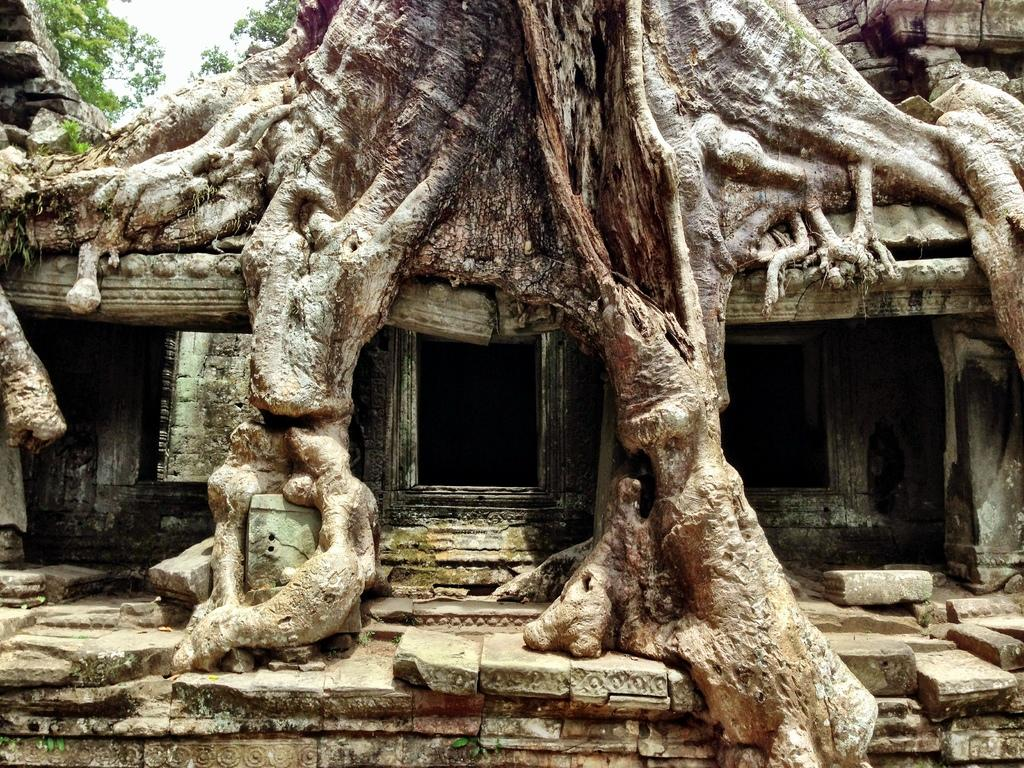What type of natural elements can be seen in the image? There are trees in the image. What architectural features are present in the image? There are windows in the image. What type of material is visible in the image? There is stone in the image. What is the color of the sky in the image? The sky is white in color. What type of sound can be heard coming from the trees in the image? There is no sound present in the image, as it is a still image and not a video or audio recording. Is there any indication of space travel or extraterrestrial life in the image? There is no indication of space travel or extraterrestrial life in the image; it features trees, windows, stone, and a white sky. 